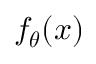<formula> <loc_0><loc_0><loc_500><loc_500>f _ { \theta } ( x )</formula> 